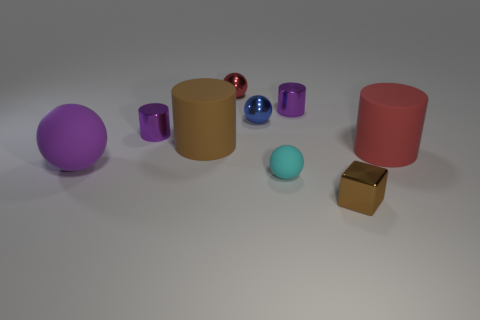The shiny block that is the same size as the red metal sphere is what color?
Provide a short and direct response. Brown. How many blocks are either big brown objects or large purple rubber things?
Keep it short and to the point. 0. What number of tiny red metallic spheres are there?
Provide a succinct answer. 1. Do the small brown shiny thing and the small purple metallic thing right of the tiny red metal ball have the same shape?
Your response must be concise. No. The cylinder that is the same color as the small cube is what size?
Your response must be concise. Large. How many things are either large blue metallic cylinders or big purple matte balls?
Keep it short and to the point. 1. The tiny metallic object that is in front of the red object that is right of the cyan rubber sphere is what shape?
Give a very brief answer. Cube. Does the red object right of the cyan rubber thing have the same shape as the brown metallic thing?
Offer a very short reply. No. What is the size of the purple object that is made of the same material as the big red thing?
Your answer should be very brief. Large. How many things are things that are on the left side of the cyan matte ball or cylinders in front of the big brown rubber cylinder?
Provide a succinct answer. 6. 